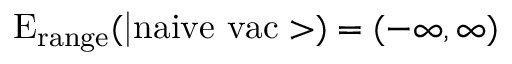<formula> <loc_0><loc_0><loc_500><loc_500>E _ { r a n g e } ( | n a i v e \ v a c > ) = ( - \infty , \infty )</formula> 